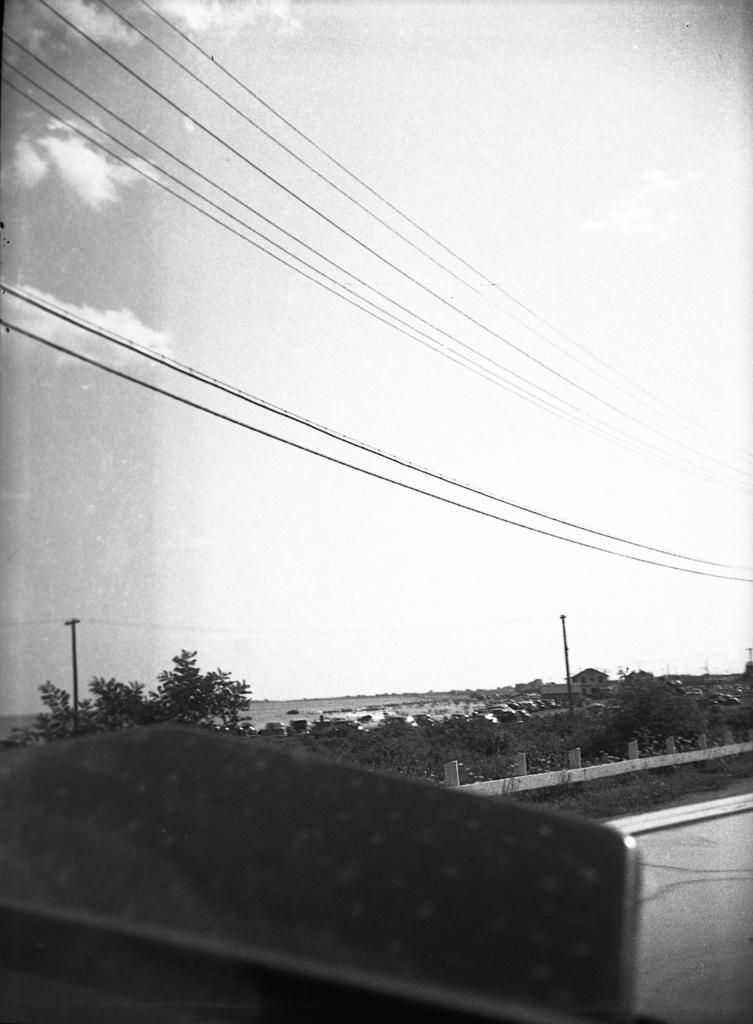Please provide a concise description of this image. It is a black and white picture. At the bottom, we can see an object. Background, there are few plants, poles, fencing, trees, houses and vehicles. Here there is the sky and few wires. 